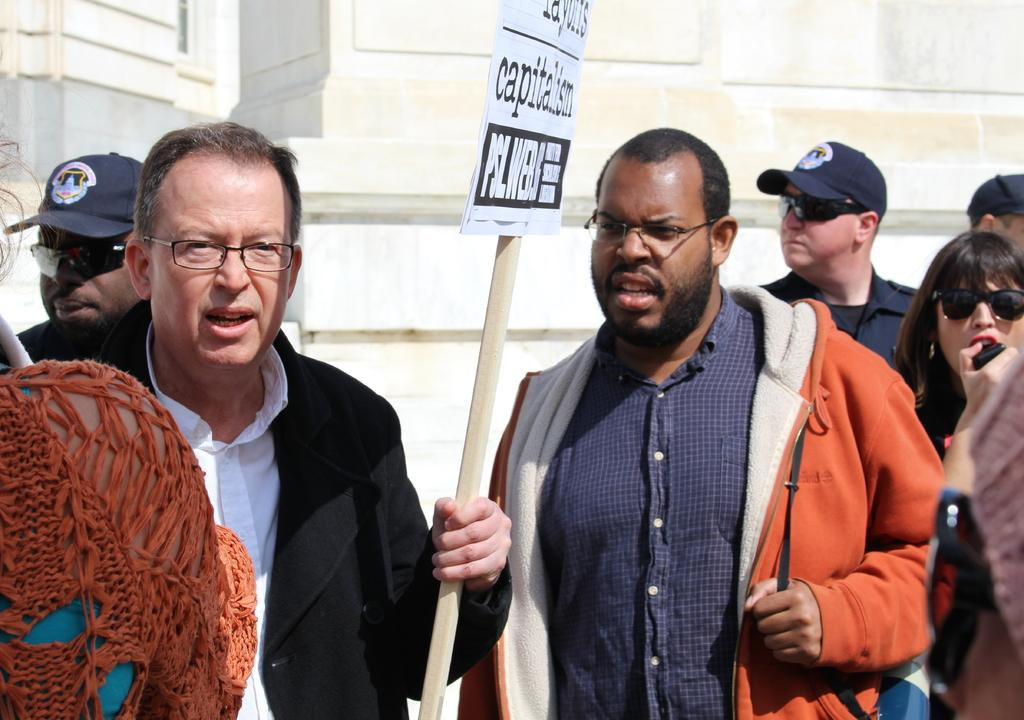What is the man in the image wearing? The man is wearing a jacket in the image. What is the man holding in the image? The man is holding a board in the image. Can you describe the people in the image? There are people in the image, but their specific actions or appearances are not mentioned in the provided facts. What can be seen in the background of the image? There is a white wall in the background of the image. What type of calculator is the man using in the image? There is no calculator present in the image; the man is holding a board. Can you provide an example of the man's communication with the people in the image? The provided facts do not give any information about the man's communication with the people in the image, so it is not possible to provide an example. 